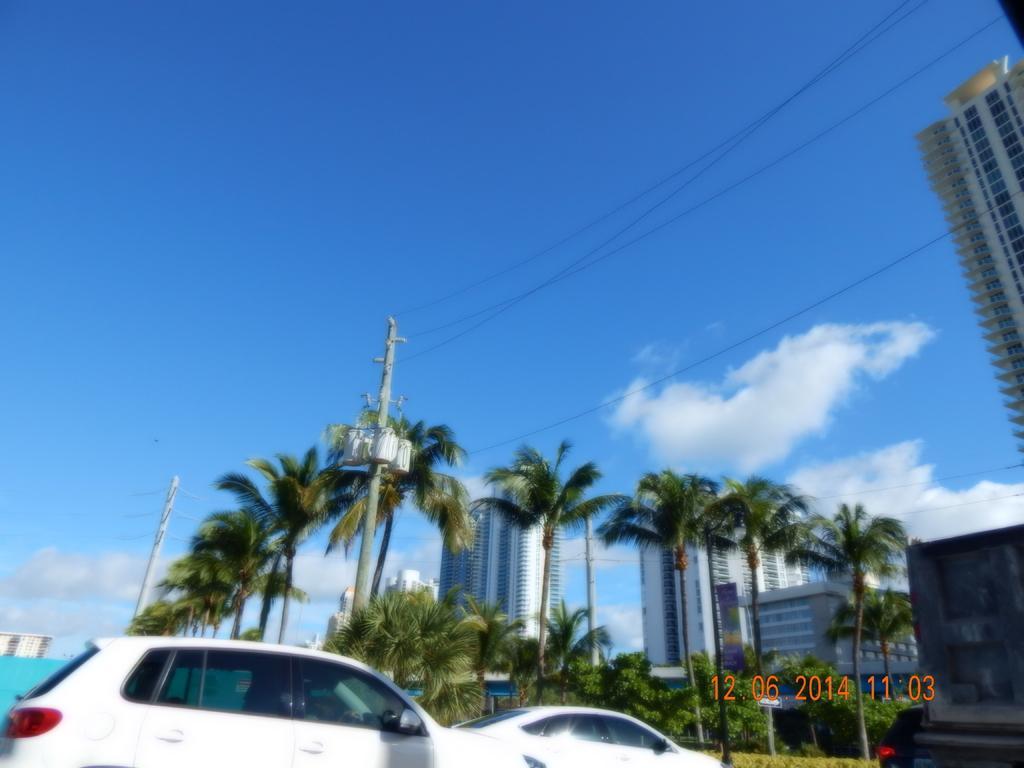How would you summarize this image in a sentence or two? In this picture I can see buildings, trees and couple of cars and I can see text at the bottom right corner of the picture and a blue cloudy sky. 